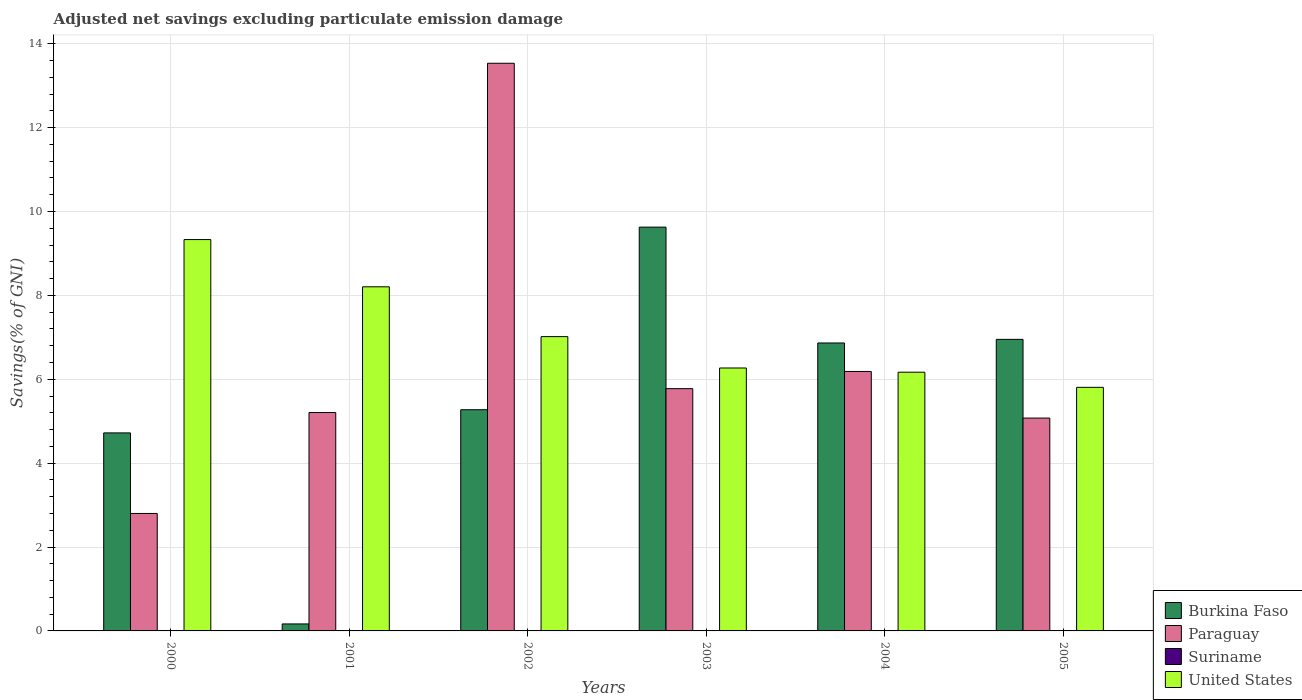How many different coloured bars are there?
Give a very brief answer. 3. Are the number of bars per tick equal to the number of legend labels?
Make the answer very short. No. How many bars are there on the 6th tick from the right?
Offer a terse response. 3. What is the adjusted net savings in United States in 2003?
Offer a terse response. 6.27. Across all years, what is the maximum adjusted net savings in United States?
Keep it short and to the point. 9.33. What is the total adjusted net savings in Paraguay in the graph?
Provide a short and direct response. 38.58. What is the difference between the adjusted net savings in United States in 2001 and that in 2005?
Make the answer very short. 2.4. What is the difference between the adjusted net savings in Paraguay in 2002 and the adjusted net savings in Burkina Faso in 2004?
Offer a terse response. 6.67. What is the average adjusted net savings in Burkina Faso per year?
Offer a terse response. 5.6. In the year 2000, what is the difference between the adjusted net savings in Burkina Faso and adjusted net savings in Paraguay?
Offer a very short reply. 1.92. In how many years, is the adjusted net savings in Burkina Faso greater than 10 %?
Keep it short and to the point. 0. What is the ratio of the adjusted net savings in Paraguay in 2000 to that in 2004?
Provide a succinct answer. 0.45. Is the adjusted net savings in Burkina Faso in 2002 less than that in 2004?
Ensure brevity in your answer.  Yes. Is the difference between the adjusted net savings in Burkina Faso in 2001 and 2004 greater than the difference between the adjusted net savings in Paraguay in 2001 and 2004?
Ensure brevity in your answer.  No. What is the difference between the highest and the second highest adjusted net savings in United States?
Your response must be concise. 1.13. What is the difference between the highest and the lowest adjusted net savings in United States?
Provide a short and direct response. 3.52. In how many years, is the adjusted net savings in United States greater than the average adjusted net savings in United States taken over all years?
Your answer should be compact. 2. Is the sum of the adjusted net savings in Paraguay in 2001 and 2003 greater than the maximum adjusted net savings in Suriname across all years?
Provide a succinct answer. Yes. Are all the bars in the graph horizontal?
Ensure brevity in your answer.  No. How many years are there in the graph?
Keep it short and to the point. 6. What is the difference between two consecutive major ticks on the Y-axis?
Provide a succinct answer. 2. How many legend labels are there?
Make the answer very short. 4. How are the legend labels stacked?
Give a very brief answer. Vertical. What is the title of the graph?
Your response must be concise. Adjusted net savings excluding particulate emission damage. What is the label or title of the X-axis?
Provide a short and direct response. Years. What is the label or title of the Y-axis?
Your answer should be compact. Savings(% of GNI). What is the Savings(% of GNI) of Burkina Faso in 2000?
Offer a very short reply. 4.72. What is the Savings(% of GNI) of Paraguay in 2000?
Keep it short and to the point. 2.8. What is the Savings(% of GNI) of United States in 2000?
Offer a very short reply. 9.33. What is the Savings(% of GNI) of Burkina Faso in 2001?
Offer a terse response. 0.17. What is the Savings(% of GNI) of Paraguay in 2001?
Provide a short and direct response. 5.21. What is the Savings(% of GNI) of United States in 2001?
Ensure brevity in your answer.  8.2. What is the Savings(% of GNI) of Burkina Faso in 2002?
Provide a short and direct response. 5.27. What is the Savings(% of GNI) of Paraguay in 2002?
Provide a succinct answer. 13.53. What is the Savings(% of GNI) in United States in 2002?
Ensure brevity in your answer.  7.02. What is the Savings(% of GNI) in Burkina Faso in 2003?
Give a very brief answer. 9.63. What is the Savings(% of GNI) of Paraguay in 2003?
Make the answer very short. 5.78. What is the Savings(% of GNI) of Suriname in 2003?
Make the answer very short. 0. What is the Savings(% of GNI) of United States in 2003?
Provide a succinct answer. 6.27. What is the Savings(% of GNI) in Burkina Faso in 2004?
Offer a very short reply. 6.86. What is the Savings(% of GNI) of Paraguay in 2004?
Give a very brief answer. 6.19. What is the Savings(% of GNI) in Suriname in 2004?
Provide a succinct answer. 0. What is the Savings(% of GNI) of United States in 2004?
Give a very brief answer. 6.17. What is the Savings(% of GNI) in Burkina Faso in 2005?
Provide a short and direct response. 6.95. What is the Savings(% of GNI) in Paraguay in 2005?
Give a very brief answer. 5.07. What is the Savings(% of GNI) in Suriname in 2005?
Offer a very short reply. 0. What is the Savings(% of GNI) in United States in 2005?
Your answer should be compact. 5.81. Across all years, what is the maximum Savings(% of GNI) in Burkina Faso?
Provide a succinct answer. 9.63. Across all years, what is the maximum Savings(% of GNI) in Paraguay?
Offer a terse response. 13.53. Across all years, what is the maximum Savings(% of GNI) in United States?
Provide a succinct answer. 9.33. Across all years, what is the minimum Savings(% of GNI) in Burkina Faso?
Ensure brevity in your answer.  0.17. Across all years, what is the minimum Savings(% of GNI) of Paraguay?
Ensure brevity in your answer.  2.8. Across all years, what is the minimum Savings(% of GNI) in United States?
Provide a succinct answer. 5.81. What is the total Savings(% of GNI) of Burkina Faso in the graph?
Provide a succinct answer. 33.6. What is the total Savings(% of GNI) of Paraguay in the graph?
Your response must be concise. 38.58. What is the total Savings(% of GNI) in United States in the graph?
Ensure brevity in your answer.  42.8. What is the difference between the Savings(% of GNI) in Burkina Faso in 2000 and that in 2001?
Keep it short and to the point. 4.55. What is the difference between the Savings(% of GNI) in Paraguay in 2000 and that in 2001?
Make the answer very short. -2.41. What is the difference between the Savings(% of GNI) of United States in 2000 and that in 2001?
Make the answer very short. 1.13. What is the difference between the Savings(% of GNI) in Burkina Faso in 2000 and that in 2002?
Keep it short and to the point. -0.55. What is the difference between the Savings(% of GNI) of Paraguay in 2000 and that in 2002?
Provide a succinct answer. -10.73. What is the difference between the Savings(% of GNI) in United States in 2000 and that in 2002?
Provide a succinct answer. 2.31. What is the difference between the Savings(% of GNI) of Burkina Faso in 2000 and that in 2003?
Offer a very short reply. -4.91. What is the difference between the Savings(% of GNI) of Paraguay in 2000 and that in 2003?
Offer a very short reply. -2.98. What is the difference between the Savings(% of GNI) of United States in 2000 and that in 2003?
Provide a succinct answer. 3.06. What is the difference between the Savings(% of GNI) of Burkina Faso in 2000 and that in 2004?
Provide a short and direct response. -2.14. What is the difference between the Savings(% of GNI) of Paraguay in 2000 and that in 2004?
Provide a short and direct response. -3.39. What is the difference between the Savings(% of GNI) in United States in 2000 and that in 2004?
Keep it short and to the point. 3.16. What is the difference between the Savings(% of GNI) of Burkina Faso in 2000 and that in 2005?
Make the answer very short. -2.23. What is the difference between the Savings(% of GNI) of Paraguay in 2000 and that in 2005?
Give a very brief answer. -2.27. What is the difference between the Savings(% of GNI) of United States in 2000 and that in 2005?
Your response must be concise. 3.52. What is the difference between the Savings(% of GNI) in Burkina Faso in 2001 and that in 2002?
Ensure brevity in your answer.  -5.11. What is the difference between the Savings(% of GNI) in Paraguay in 2001 and that in 2002?
Keep it short and to the point. -8.33. What is the difference between the Savings(% of GNI) of United States in 2001 and that in 2002?
Make the answer very short. 1.19. What is the difference between the Savings(% of GNI) of Burkina Faso in 2001 and that in 2003?
Make the answer very short. -9.46. What is the difference between the Savings(% of GNI) in Paraguay in 2001 and that in 2003?
Your response must be concise. -0.57. What is the difference between the Savings(% of GNI) of United States in 2001 and that in 2003?
Keep it short and to the point. 1.94. What is the difference between the Savings(% of GNI) of Burkina Faso in 2001 and that in 2004?
Your answer should be very brief. -6.7. What is the difference between the Savings(% of GNI) of Paraguay in 2001 and that in 2004?
Give a very brief answer. -0.98. What is the difference between the Savings(% of GNI) in United States in 2001 and that in 2004?
Offer a very short reply. 2.04. What is the difference between the Savings(% of GNI) in Burkina Faso in 2001 and that in 2005?
Your answer should be compact. -6.78. What is the difference between the Savings(% of GNI) in Paraguay in 2001 and that in 2005?
Provide a short and direct response. 0.13. What is the difference between the Savings(% of GNI) of United States in 2001 and that in 2005?
Keep it short and to the point. 2.4. What is the difference between the Savings(% of GNI) in Burkina Faso in 2002 and that in 2003?
Provide a succinct answer. -4.35. What is the difference between the Savings(% of GNI) of Paraguay in 2002 and that in 2003?
Offer a terse response. 7.76. What is the difference between the Savings(% of GNI) of United States in 2002 and that in 2003?
Ensure brevity in your answer.  0.75. What is the difference between the Savings(% of GNI) of Burkina Faso in 2002 and that in 2004?
Keep it short and to the point. -1.59. What is the difference between the Savings(% of GNI) of Paraguay in 2002 and that in 2004?
Ensure brevity in your answer.  7.35. What is the difference between the Savings(% of GNI) of United States in 2002 and that in 2004?
Your answer should be very brief. 0.85. What is the difference between the Savings(% of GNI) of Burkina Faso in 2002 and that in 2005?
Ensure brevity in your answer.  -1.68. What is the difference between the Savings(% of GNI) of Paraguay in 2002 and that in 2005?
Offer a very short reply. 8.46. What is the difference between the Savings(% of GNI) of United States in 2002 and that in 2005?
Your answer should be very brief. 1.21. What is the difference between the Savings(% of GNI) in Burkina Faso in 2003 and that in 2004?
Provide a succinct answer. 2.76. What is the difference between the Savings(% of GNI) of Paraguay in 2003 and that in 2004?
Provide a succinct answer. -0.41. What is the difference between the Savings(% of GNI) in United States in 2003 and that in 2004?
Your answer should be very brief. 0.1. What is the difference between the Savings(% of GNI) in Burkina Faso in 2003 and that in 2005?
Ensure brevity in your answer.  2.68. What is the difference between the Savings(% of GNI) in Paraguay in 2003 and that in 2005?
Your response must be concise. 0.7. What is the difference between the Savings(% of GNI) of United States in 2003 and that in 2005?
Keep it short and to the point. 0.46. What is the difference between the Savings(% of GNI) of Burkina Faso in 2004 and that in 2005?
Your response must be concise. -0.09. What is the difference between the Savings(% of GNI) of Paraguay in 2004 and that in 2005?
Offer a terse response. 1.11. What is the difference between the Savings(% of GNI) in United States in 2004 and that in 2005?
Keep it short and to the point. 0.36. What is the difference between the Savings(% of GNI) of Burkina Faso in 2000 and the Savings(% of GNI) of Paraguay in 2001?
Give a very brief answer. -0.49. What is the difference between the Savings(% of GNI) of Burkina Faso in 2000 and the Savings(% of GNI) of United States in 2001?
Offer a very short reply. -3.48. What is the difference between the Savings(% of GNI) in Paraguay in 2000 and the Savings(% of GNI) in United States in 2001?
Offer a terse response. -5.4. What is the difference between the Savings(% of GNI) of Burkina Faso in 2000 and the Savings(% of GNI) of Paraguay in 2002?
Offer a very short reply. -8.81. What is the difference between the Savings(% of GNI) of Burkina Faso in 2000 and the Savings(% of GNI) of United States in 2002?
Give a very brief answer. -2.3. What is the difference between the Savings(% of GNI) in Paraguay in 2000 and the Savings(% of GNI) in United States in 2002?
Keep it short and to the point. -4.22. What is the difference between the Savings(% of GNI) of Burkina Faso in 2000 and the Savings(% of GNI) of Paraguay in 2003?
Keep it short and to the point. -1.05. What is the difference between the Savings(% of GNI) of Burkina Faso in 2000 and the Savings(% of GNI) of United States in 2003?
Your response must be concise. -1.55. What is the difference between the Savings(% of GNI) of Paraguay in 2000 and the Savings(% of GNI) of United States in 2003?
Provide a short and direct response. -3.47. What is the difference between the Savings(% of GNI) of Burkina Faso in 2000 and the Savings(% of GNI) of Paraguay in 2004?
Make the answer very short. -1.46. What is the difference between the Savings(% of GNI) in Burkina Faso in 2000 and the Savings(% of GNI) in United States in 2004?
Offer a very short reply. -1.45. What is the difference between the Savings(% of GNI) in Paraguay in 2000 and the Savings(% of GNI) in United States in 2004?
Keep it short and to the point. -3.37. What is the difference between the Savings(% of GNI) in Burkina Faso in 2000 and the Savings(% of GNI) in Paraguay in 2005?
Your answer should be compact. -0.35. What is the difference between the Savings(% of GNI) of Burkina Faso in 2000 and the Savings(% of GNI) of United States in 2005?
Your answer should be very brief. -1.09. What is the difference between the Savings(% of GNI) in Paraguay in 2000 and the Savings(% of GNI) in United States in 2005?
Offer a very short reply. -3.01. What is the difference between the Savings(% of GNI) of Burkina Faso in 2001 and the Savings(% of GNI) of Paraguay in 2002?
Offer a terse response. -13.37. What is the difference between the Savings(% of GNI) in Burkina Faso in 2001 and the Savings(% of GNI) in United States in 2002?
Provide a succinct answer. -6.85. What is the difference between the Savings(% of GNI) of Paraguay in 2001 and the Savings(% of GNI) of United States in 2002?
Provide a short and direct response. -1.81. What is the difference between the Savings(% of GNI) in Burkina Faso in 2001 and the Savings(% of GNI) in Paraguay in 2003?
Provide a short and direct response. -5.61. What is the difference between the Savings(% of GNI) of Burkina Faso in 2001 and the Savings(% of GNI) of United States in 2003?
Keep it short and to the point. -6.1. What is the difference between the Savings(% of GNI) in Paraguay in 2001 and the Savings(% of GNI) in United States in 2003?
Keep it short and to the point. -1.06. What is the difference between the Savings(% of GNI) of Burkina Faso in 2001 and the Savings(% of GNI) of Paraguay in 2004?
Keep it short and to the point. -6.02. What is the difference between the Savings(% of GNI) of Burkina Faso in 2001 and the Savings(% of GNI) of United States in 2004?
Keep it short and to the point. -6. What is the difference between the Savings(% of GNI) in Paraguay in 2001 and the Savings(% of GNI) in United States in 2004?
Your response must be concise. -0.96. What is the difference between the Savings(% of GNI) in Burkina Faso in 2001 and the Savings(% of GNI) in Paraguay in 2005?
Give a very brief answer. -4.91. What is the difference between the Savings(% of GNI) of Burkina Faso in 2001 and the Savings(% of GNI) of United States in 2005?
Offer a terse response. -5.64. What is the difference between the Savings(% of GNI) in Paraguay in 2001 and the Savings(% of GNI) in United States in 2005?
Your answer should be compact. -0.6. What is the difference between the Savings(% of GNI) in Burkina Faso in 2002 and the Savings(% of GNI) in Paraguay in 2003?
Offer a very short reply. -0.5. What is the difference between the Savings(% of GNI) in Burkina Faso in 2002 and the Savings(% of GNI) in United States in 2003?
Keep it short and to the point. -0.99. What is the difference between the Savings(% of GNI) in Paraguay in 2002 and the Savings(% of GNI) in United States in 2003?
Keep it short and to the point. 7.27. What is the difference between the Savings(% of GNI) in Burkina Faso in 2002 and the Savings(% of GNI) in Paraguay in 2004?
Offer a very short reply. -0.91. What is the difference between the Savings(% of GNI) of Burkina Faso in 2002 and the Savings(% of GNI) of United States in 2004?
Your answer should be compact. -0.89. What is the difference between the Savings(% of GNI) in Paraguay in 2002 and the Savings(% of GNI) in United States in 2004?
Ensure brevity in your answer.  7.37. What is the difference between the Savings(% of GNI) in Burkina Faso in 2002 and the Savings(% of GNI) in Paraguay in 2005?
Offer a very short reply. 0.2. What is the difference between the Savings(% of GNI) in Burkina Faso in 2002 and the Savings(% of GNI) in United States in 2005?
Provide a short and direct response. -0.53. What is the difference between the Savings(% of GNI) of Paraguay in 2002 and the Savings(% of GNI) of United States in 2005?
Your answer should be compact. 7.73. What is the difference between the Savings(% of GNI) in Burkina Faso in 2003 and the Savings(% of GNI) in Paraguay in 2004?
Provide a short and direct response. 3.44. What is the difference between the Savings(% of GNI) of Burkina Faso in 2003 and the Savings(% of GNI) of United States in 2004?
Your answer should be very brief. 3.46. What is the difference between the Savings(% of GNI) in Paraguay in 2003 and the Savings(% of GNI) in United States in 2004?
Provide a succinct answer. -0.39. What is the difference between the Savings(% of GNI) in Burkina Faso in 2003 and the Savings(% of GNI) in Paraguay in 2005?
Your response must be concise. 4.55. What is the difference between the Savings(% of GNI) in Burkina Faso in 2003 and the Savings(% of GNI) in United States in 2005?
Offer a very short reply. 3.82. What is the difference between the Savings(% of GNI) in Paraguay in 2003 and the Savings(% of GNI) in United States in 2005?
Make the answer very short. -0.03. What is the difference between the Savings(% of GNI) of Burkina Faso in 2004 and the Savings(% of GNI) of Paraguay in 2005?
Your answer should be very brief. 1.79. What is the difference between the Savings(% of GNI) of Burkina Faso in 2004 and the Savings(% of GNI) of United States in 2005?
Give a very brief answer. 1.06. What is the difference between the Savings(% of GNI) of Paraguay in 2004 and the Savings(% of GNI) of United States in 2005?
Ensure brevity in your answer.  0.38. What is the average Savings(% of GNI) in Burkina Faso per year?
Provide a short and direct response. 5.6. What is the average Savings(% of GNI) in Paraguay per year?
Keep it short and to the point. 6.43. What is the average Savings(% of GNI) in United States per year?
Make the answer very short. 7.13. In the year 2000, what is the difference between the Savings(% of GNI) in Burkina Faso and Savings(% of GNI) in Paraguay?
Offer a terse response. 1.92. In the year 2000, what is the difference between the Savings(% of GNI) of Burkina Faso and Savings(% of GNI) of United States?
Offer a very short reply. -4.61. In the year 2000, what is the difference between the Savings(% of GNI) in Paraguay and Savings(% of GNI) in United States?
Your answer should be very brief. -6.53. In the year 2001, what is the difference between the Savings(% of GNI) of Burkina Faso and Savings(% of GNI) of Paraguay?
Offer a terse response. -5.04. In the year 2001, what is the difference between the Savings(% of GNI) of Burkina Faso and Savings(% of GNI) of United States?
Provide a succinct answer. -8.04. In the year 2001, what is the difference between the Savings(% of GNI) of Paraguay and Savings(% of GNI) of United States?
Make the answer very short. -3. In the year 2002, what is the difference between the Savings(% of GNI) in Burkina Faso and Savings(% of GNI) in Paraguay?
Keep it short and to the point. -8.26. In the year 2002, what is the difference between the Savings(% of GNI) of Burkina Faso and Savings(% of GNI) of United States?
Your response must be concise. -1.74. In the year 2002, what is the difference between the Savings(% of GNI) of Paraguay and Savings(% of GNI) of United States?
Offer a terse response. 6.52. In the year 2003, what is the difference between the Savings(% of GNI) of Burkina Faso and Savings(% of GNI) of Paraguay?
Your answer should be compact. 3.85. In the year 2003, what is the difference between the Savings(% of GNI) of Burkina Faso and Savings(% of GNI) of United States?
Offer a very short reply. 3.36. In the year 2003, what is the difference between the Savings(% of GNI) in Paraguay and Savings(% of GNI) in United States?
Your answer should be very brief. -0.49. In the year 2004, what is the difference between the Savings(% of GNI) in Burkina Faso and Savings(% of GNI) in Paraguay?
Provide a succinct answer. 0.68. In the year 2004, what is the difference between the Savings(% of GNI) of Burkina Faso and Savings(% of GNI) of United States?
Your answer should be compact. 0.7. In the year 2004, what is the difference between the Savings(% of GNI) in Paraguay and Savings(% of GNI) in United States?
Make the answer very short. 0.02. In the year 2005, what is the difference between the Savings(% of GNI) in Burkina Faso and Savings(% of GNI) in Paraguay?
Offer a very short reply. 1.88. In the year 2005, what is the difference between the Savings(% of GNI) in Burkina Faso and Savings(% of GNI) in United States?
Your answer should be compact. 1.14. In the year 2005, what is the difference between the Savings(% of GNI) of Paraguay and Savings(% of GNI) of United States?
Offer a very short reply. -0.73. What is the ratio of the Savings(% of GNI) of Burkina Faso in 2000 to that in 2001?
Give a very brief answer. 28.34. What is the ratio of the Savings(% of GNI) in Paraguay in 2000 to that in 2001?
Provide a short and direct response. 0.54. What is the ratio of the Savings(% of GNI) of United States in 2000 to that in 2001?
Offer a very short reply. 1.14. What is the ratio of the Savings(% of GNI) of Burkina Faso in 2000 to that in 2002?
Your response must be concise. 0.9. What is the ratio of the Savings(% of GNI) in Paraguay in 2000 to that in 2002?
Make the answer very short. 0.21. What is the ratio of the Savings(% of GNI) of United States in 2000 to that in 2002?
Make the answer very short. 1.33. What is the ratio of the Savings(% of GNI) of Burkina Faso in 2000 to that in 2003?
Offer a very short reply. 0.49. What is the ratio of the Savings(% of GNI) in Paraguay in 2000 to that in 2003?
Keep it short and to the point. 0.48. What is the ratio of the Savings(% of GNI) in United States in 2000 to that in 2003?
Make the answer very short. 1.49. What is the ratio of the Savings(% of GNI) in Burkina Faso in 2000 to that in 2004?
Ensure brevity in your answer.  0.69. What is the ratio of the Savings(% of GNI) in Paraguay in 2000 to that in 2004?
Offer a terse response. 0.45. What is the ratio of the Savings(% of GNI) in United States in 2000 to that in 2004?
Your answer should be compact. 1.51. What is the ratio of the Savings(% of GNI) of Burkina Faso in 2000 to that in 2005?
Provide a short and direct response. 0.68. What is the ratio of the Savings(% of GNI) of Paraguay in 2000 to that in 2005?
Offer a terse response. 0.55. What is the ratio of the Savings(% of GNI) of United States in 2000 to that in 2005?
Your answer should be very brief. 1.61. What is the ratio of the Savings(% of GNI) in Burkina Faso in 2001 to that in 2002?
Give a very brief answer. 0.03. What is the ratio of the Savings(% of GNI) in Paraguay in 2001 to that in 2002?
Give a very brief answer. 0.38. What is the ratio of the Savings(% of GNI) in United States in 2001 to that in 2002?
Provide a short and direct response. 1.17. What is the ratio of the Savings(% of GNI) in Burkina Faso in 2001 to that in 2003?
Keep it short and to the point. 0.02. What is the ratio of the Savings(% of GNI) of Paraguay in 2001 to that in 2003?
Offer a very short reply. 0.9. What is the ratio of the Savings(% of GNI) of United States in 2001 to that in 2003?
Provide a short and direct response. 1.31. What is the ratio of the Savings(% of GNI) of Burkina Faso in 2001 to that in 2004?
Give a very brief answer. 0.02. What is the ratio of the Savings(% of GNI) in Paraguay in 2001 to that in 2004?
Keep it short and to the point. 0.84. What is the ratio of the Savings(% of GNI) in United States in 2001 to that in 2004?
Your answer should be compact. 1.33. What is the ratio of the Savings(% of GNI) of Burkina Faso in 2001 to that in 2005?
Offer a very short reply. 0.02. What is the ratio of the Savings(% of GNI) in Paraguay in 2001 to that in 2005?
Keep it short and to the point. 1.03. What is the ratio of the Savings(% of GNI) of United States in 2001 to that in 2005?
Offer a very short reply. 1.41. What is the ratio of the Savings(% of GNI) of Burkina Faso in 2002 to that in 2003?
Your answer should be very brief. 0.55. What is the ratio of the Savings(% of GNI) of Paraguay in 2002 to that in 2003?
Provide a short and direct response. 2.34. What is the ratio of the Savings(% of GNI) in United States in 2002 to that in 2003?
Keep it short and to the point. 1.12. What is the ratio of the Savings(% of GNI) in Burkina Faso in 2002 to that in 2004?
Keep it short and to the point. 0.77. What is the ratio of the Savings(% of GNI) in Paraguay in 2002 to that in 2004?
Provide a short and direct response. 2.19. What is the ratio of the Savings(% of GNI) of United States in 2002 to that in 2004?
Make the answer very short. 1.14. What is the ratio of the Savings(% of GNI) in Burkina Faso in 2002 to that in 2005?
Keep it short and to the point. 0.76. What is the ratio of the Savings(% of GNI) in Paraguay in 2002 to that in 2005?
Your answer should be very brief. 2.67. What is the ratio of the Savings(% of GNI) of United States in 2002 to that in 2005?
Make the answer very short. 1.21. What is the ratio of the Savings(% of GNI) of Burkina Faso in 2003 to that in 2004?
Your answer should be compact. 1.4. What is the ratio of the Savings(% of GNI) in Paraguay in 2003 to that in 2004?
Provide a succinct answer. 0.93. What is the ratio of the Savings(% of GNI) of United States in 2003 to that in 2004?
Keep it short and to the point. 1.02. What is the ratio of the Savings(% of GNI) of Burkina Faso in 2003 to that in 2005?
Provide a succinct answer. 1.39. What is the ratio of the Savings(% of GNI) in Paraguay in 2003 to that in 2005?
Keep it short and to the point. 1.14. What is the ratio of the Savings(% of GNI) of United States in 2003 to that in 2005?
Your response must be concise. 1.08. What is the ratio of the Savings(% of GNI) in Burkina Faso in 2004 to that in 2005?
Your response must be concise. 0.99. What is the ratio of the Savings(% of GNI) in Paraguay in 2004 to that in 2005?
Offer a very short reply. 1.22. What is the ratio of the Savings(% of GNI) of United States in 2004 to that in 2005?
Your response must be concise. 1.06. What is the difference between the highest and the second highest Savings(% of GNI) of Burkina Faso?
Make the answer very short. 2.68. What is the difference between the highest and the second highest Savings(% of GNI) in Paraguay?
Provide a short and direct response. 7.35. What is the difference between the highest and the second highest Savings(% of GNI) in United States?
Your answer should be compact. 1.13. What is the difference between the highest and the lowest Savings(% of GNI) in Burkina Faso?
Make the answer very short. 9.46. What is the difference between the highest and the lowest Savings(% of GNI) in Paraguay?
Your answer should be compact. 10.73. What is the difference between the highest and the lowest Savings(% of GNI) in United States?
Keep it short and to the point. 3.52. 